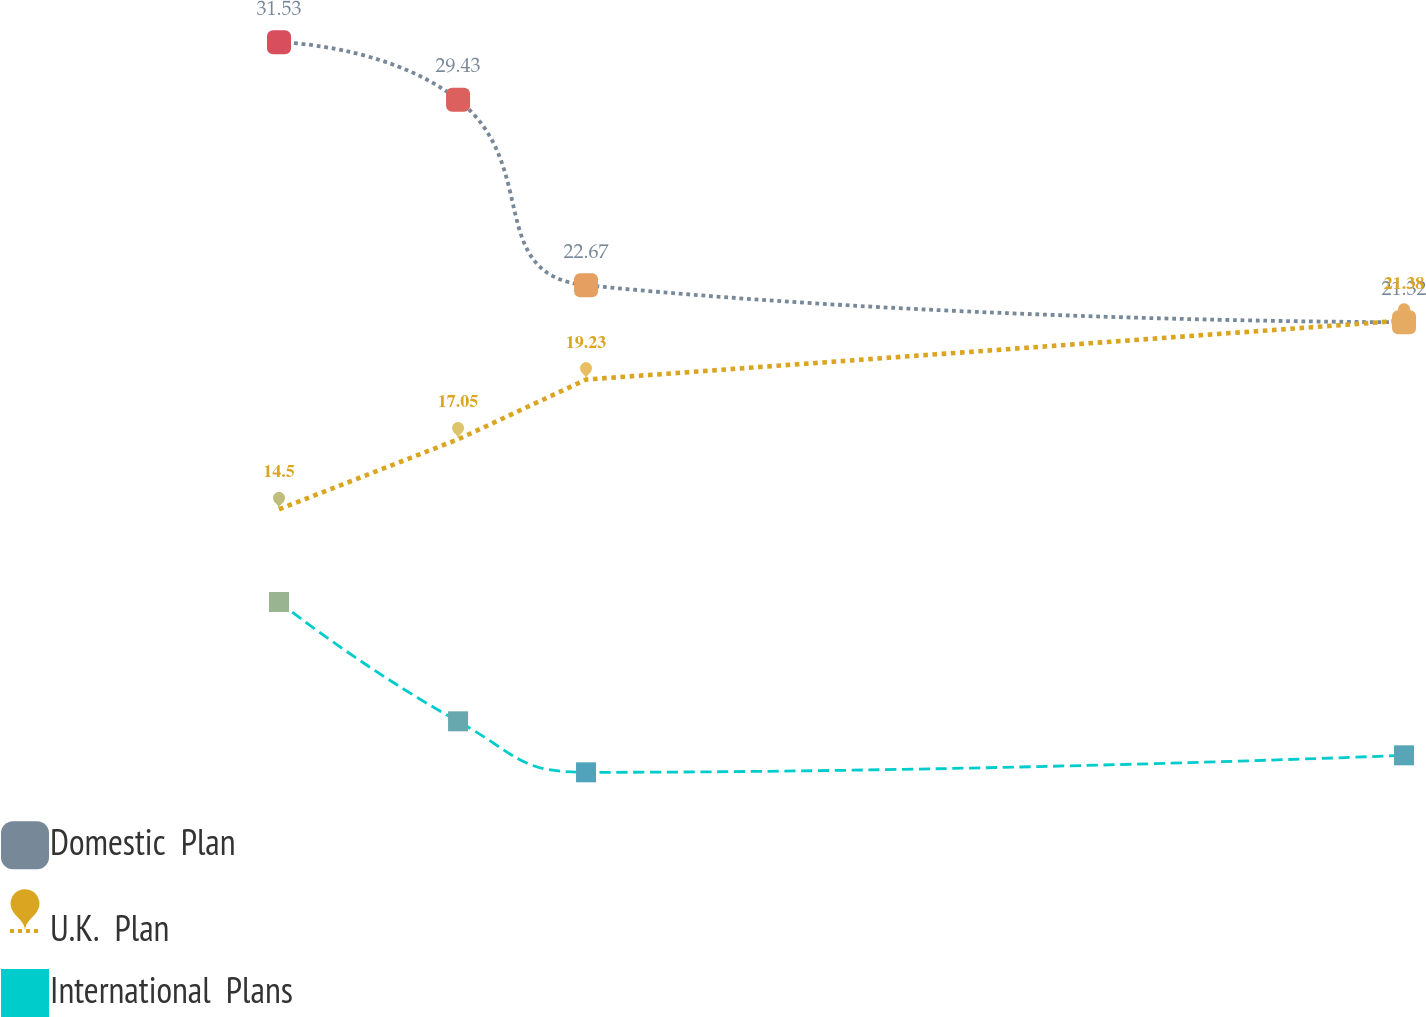Convert chart to OTSL. <chart><loc_0><loc_0><loc_500><loc_500><line_chart><ecel><fcel>Domestic  Plan<fcel>U.K.  Plan<fcel>International  Plans<nl><fcel>1627.78<fcel>31.53<fcel>14.5<fcel>11.12<nl><fcel>1700.19<fcel>29.43<fcel>17.05<fcel>6.77<nl><fcel>1751.95<fcel>22.67<fcel>19.23<fcel>4.91<nl><fcel>2082.76<fcel>21.32<fcel>21.38<fcel>5.53<nl><fcel>2145.43<fcel>24.42<fcel>18.35<fcel>6.15<nl></chart> 